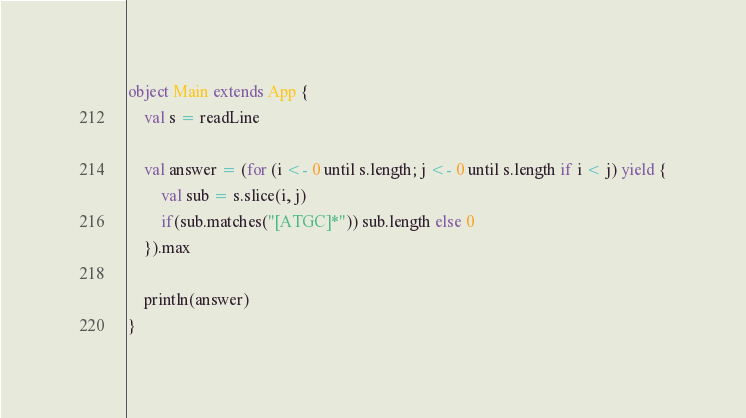<code> <loc_0><loc_0><loc_500><loc_500><_Scala_>object Main extends App {
    val s = readLine

    val answer = (for (i <- 0 until s.length; j <- 0 until s.length if i < j) yield {
        val sub = s.slice(i, j)
        if(sub.matches("[ATGC]*")) sub.length else 0
    }).max

    println(answer)
}</code> 